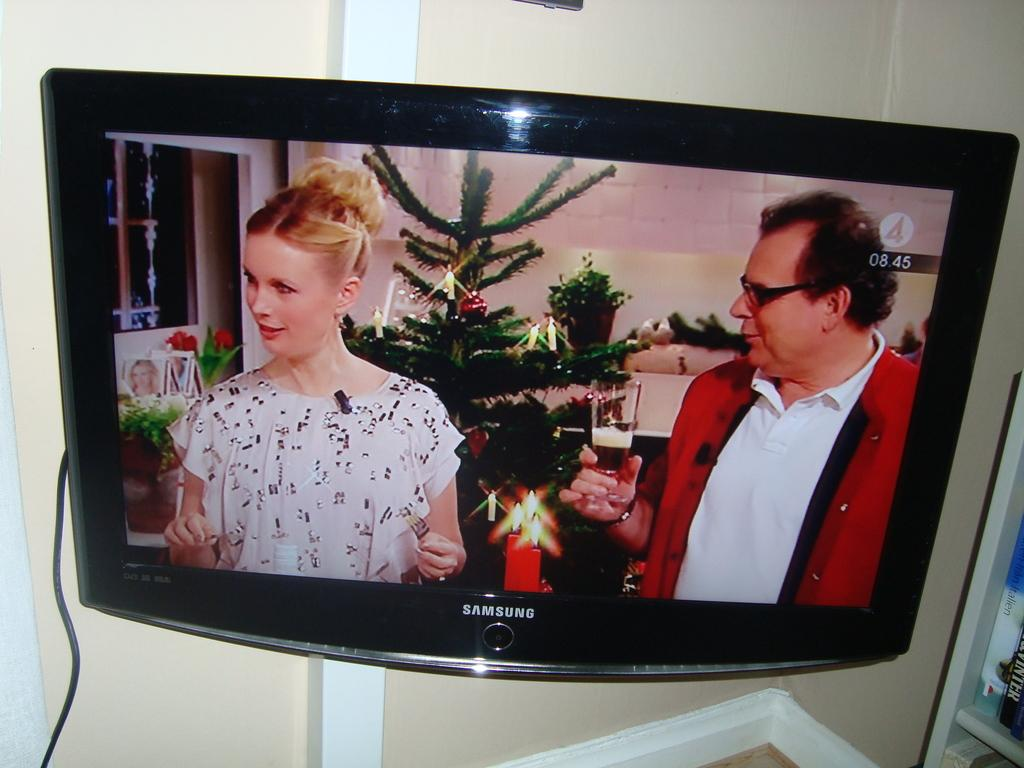<image>
Create a compact narrative representing the image presented. A Christmas tree is shown on a Samsung screen. 